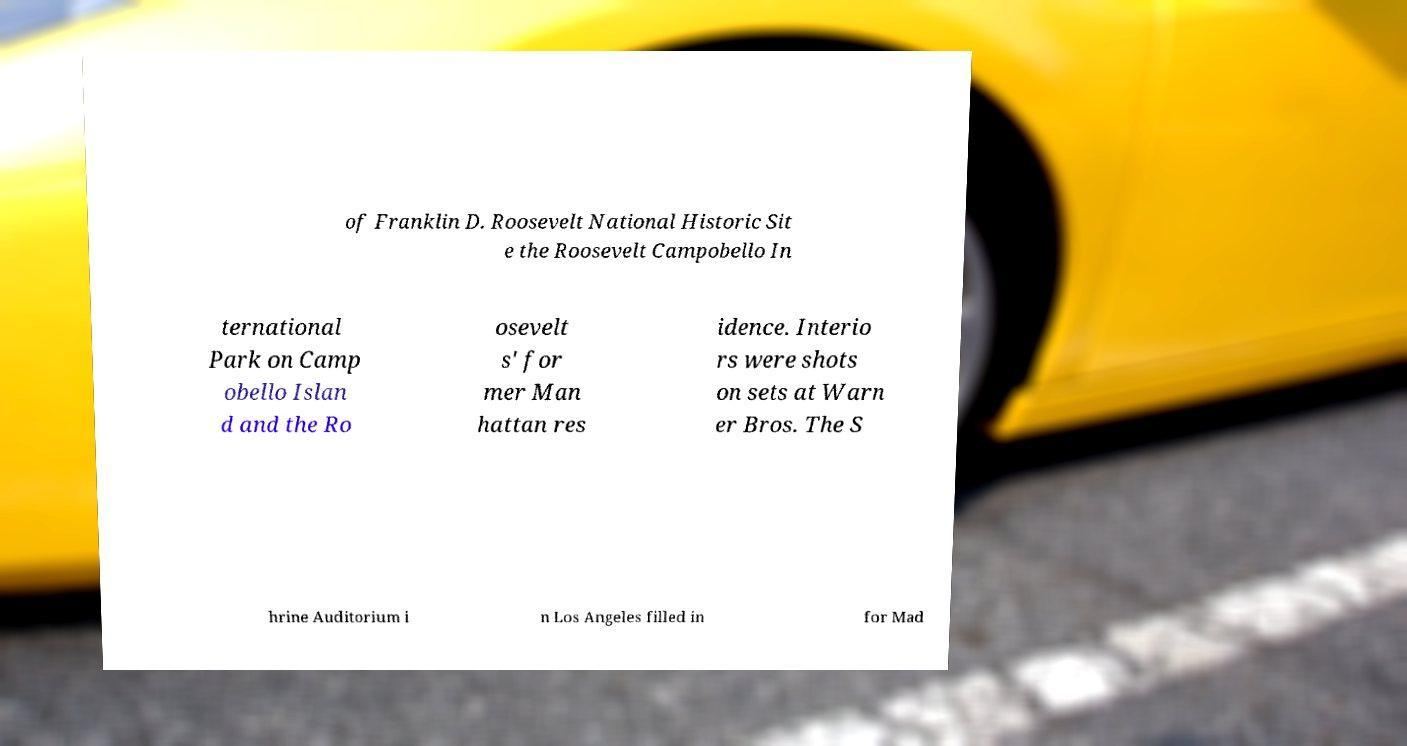Please read and relay the text visible in this image. What does it say? of Franklin D. Roosevelt National Historic Sit e the Roosevelt Campobello In ternational Park on Camp obello Islan d and the Ro osevelt s' for mer Man hattan res idence. Interio rs were shots on sets at Warn er Bros. The S hrine Auditorium i n Los Angeles filled in for Mad 